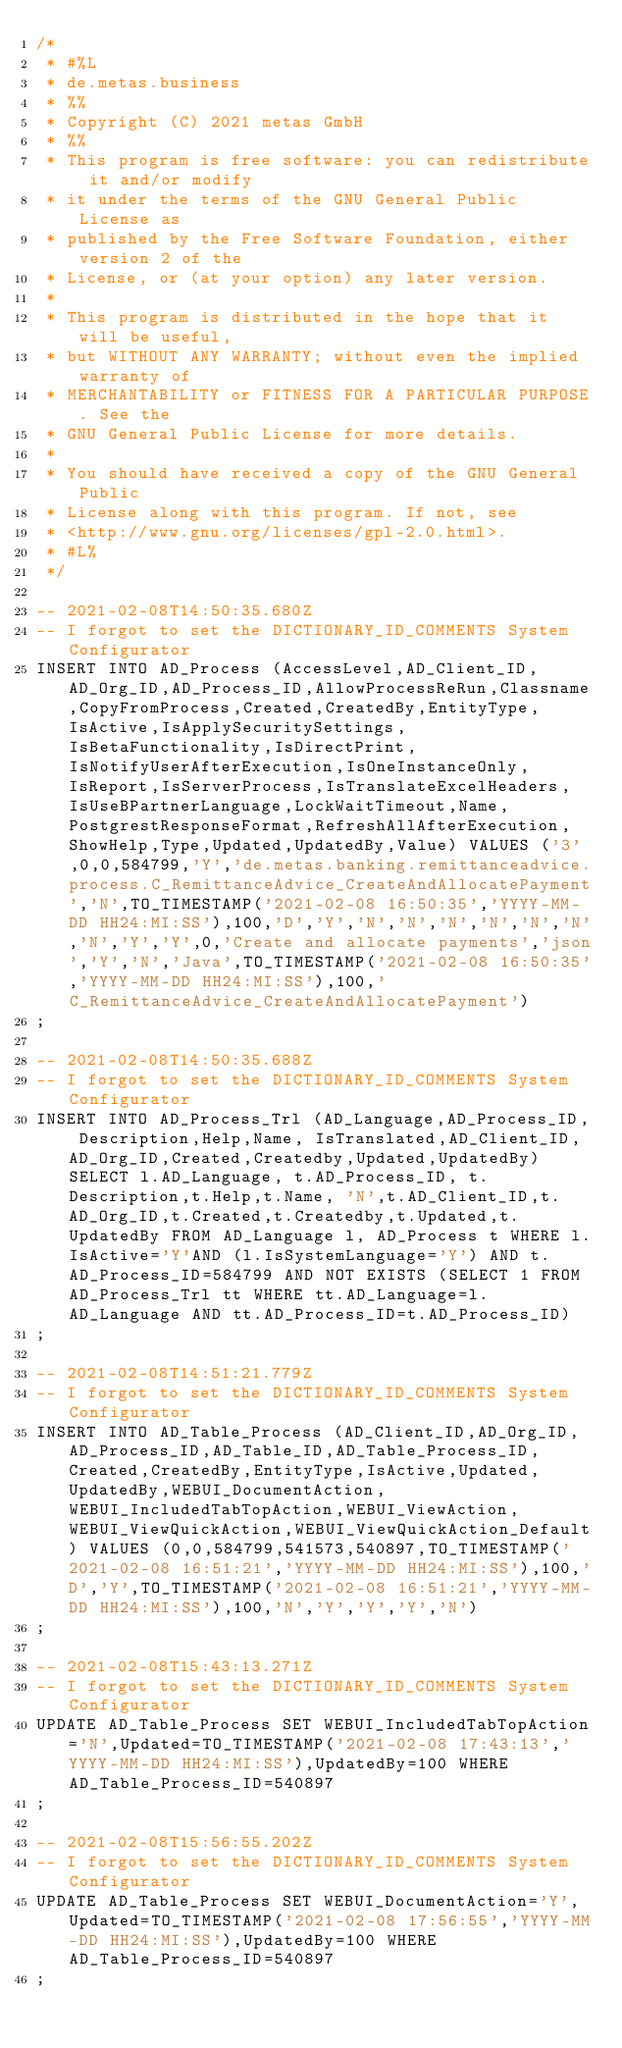<code> <loc_0><loc_0><loc_500><loc_500><_SQL_>/*
 * #%L
 * de.metas.business
 * %%
 * Copyright (C) 2021 metas GmbH
 * %%
 * This program is free software: you can redistribute it and/or modify
 * it under the terms of the GNU General Public License as
 * published by the Free Software Foundation, either version 2 of the
 * License, or (at your option) any later version.
 *
 * This program is distributed in the hope that it will be useful,
 * but WITHOUT ANY WARRANTY; without even the implied warranty of
 * MERCHANTABILITY or FITNESS FOR A PARTICULAR PURPOSE. See the
 * GNU General Public License for more details.
 *
 * You should have received a copy of the GNU General Public
 * License along with this program. If not, see
 * <http://www.gnu.org/licenses/gpl-2.0.html>.
 * #L%
 */

-- 2021-02-08T14:50:35.680Z
-- I forgot to set the DICTIONARY_ID_COMMENTS System Configurator
INSERT INTO AD_Process (AccessLevel,AD_Client_ID,AD_Org_ID,AD_Process_ID,AllowProcessReRun,Classname,CopyFromProcess,Created,CreatedBy,EntityType,IsActive,IsApplySecuritySettings,IsBetaFunctionality,IsDirectPrint,IsNotifyUserAfterExecution,IsOneInstanceOnly,IsReport,IsServerProcess,IsTranslateExcelHeaders,IsUseBPartnerLanguage,LockWaitTimeout,Name,PostgrestResponseFormat,RefreshAllAfterExecution,ShowHelp,Type,Updated,UpdatedBy,Value) VALUES ('3',0,0,584799,'Y','de.metas.banking.remittanceadvice.process.C_RemittanceAdvice_CreateAndAllocatePayment','N',TO_TIMESTAMP('2021-02-08 16:50:35','YYYY-MM-DD HH24:MI:SS'),100,'D','Y','N','N','N','N','N','N','N','Y','Y',0,'Create and allocate payments','json','Y','N','Java',TO_TIMESTAMP('2021-02-08 16:50:35','YYYY-MM-DD HH24:MI:SS'),100,'C_RemittanceAdvice_CreateAndAllocatePayment')
;

-- 2021-02-08T14:50:35.688Z
-- I forgot to set the DICTIONARY_ID_COMMENTS System Configurator
INSERT INTO AD_Process_Trl (AD_Language,AD_Process_ID, Description,Help,Name, IsTranslated,AD_Client_ID,AD_Org_ID,Created,Createdby,Updated,UpdatedBy) SELECT l.AD_Language, t.AD_Process_ID, t.Description,t.Help,t.Name, 'N',t.AD_Client_ID,t.AD_Org_ID,t.Created,t.Createdby,t.Updated,t.UpdatedBy FROM AD_Language l, AD_Process t WHERE l.IsActive='Y'AND (l.IsSystemLanguage='Y') AND t.AD_Process_ID=584799 AND NOT EXISTS (SELECT 1 FROM AD_Process_Trl tt WHERE tt.AD_Language=l.AD_Language AND tt.AD_Process_ID=t.AD_Process_ID)
;

-- 2021-02-08T14:51:21.779Z
-- I forgot to set the DICTIONARY_ID_COMMENTS System Configurator
INSERT INTO AD_Table_Process (AD_Client_ID,AD_Org_ID,AD_Process_ID,AD_Table_ID,AD_Table_Process_ID,Created,CreatedBy,EntityType,IsActive,Updated,UpdatedBy,WEBUI_DocumentAction,WEBUI_IncludedTabTopAction,WEBUI_ViewAction,WEBUI_ViewQuickAction,WEBUI_ViewQuickAction_Default) VALUES (0,0,584799,541573,540897,TO_TIMESTAMP('2021-02-08 16:51:21','YYYY-MM-DD HH24:MI:SS'),100,'D','Y',TO_TIMESTAMP('2021-02-08 16:51:21','YYYY-MM-DD HH24:MI:SS'),100,'N','Y','Y','Y','N')
;

-- 2021-02-08T15:43:13.271Z
-- I forgot to set the DICTIONARY_ID_COMMENTS System Configurator
UPDATE AD_Table_Process SET WEBUI_IncludedTabTopAction='N',Updated=TO_TIMESTAMP('2021-02-08 17:43:13','YYYY-MM-DD HH24:MI:SS'),UpdatedBy=100 WHERE AD_Table_Process_ID=540897
;

-- 2021-02-08T15:56:55.202Z
-- I forgot to set the DICTIONARY_ID_COMMENTS System Configurator
UPDATE AD_Table_Process SET WEBUI_DocumentAction='Y',Updated=TO_TIMESTAMP('2021-02-08 17:56:55','YYYY-MM-DD HH24:MI:SS'),UpdatedBy=100 WHERE AD_Table_Process_ID=540897
;

</code> 